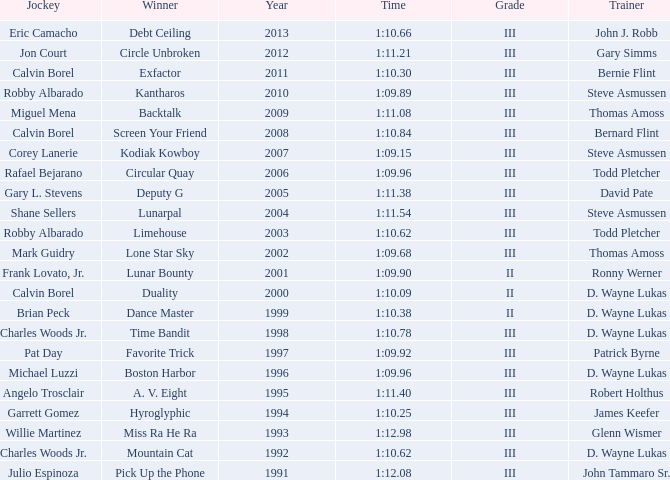Who won under Gary Simms? Circle Unbroken. 